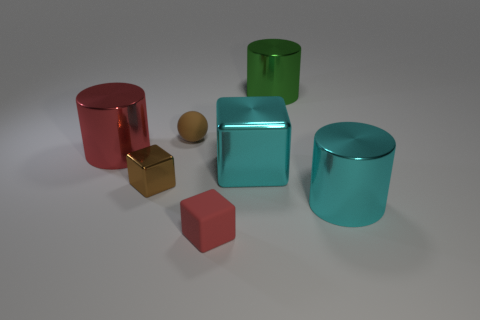How many objects are either objects in front of the big cyan metal cylinder or brown metallic things left of the big cyan cube?
Make the answer very short. 2. Is the number of red spheres less than the number of tiny spheres?
Give a very brief answer. Yes. Is the size of the brown matte thing the same as the cylinder that is to the left of the rubber cube?
Your answer should be compact. No. How many metallic things are either tiny red objects or cubes?
Your answer should be very brief. 2. Is the number of tiny red rubber things greater than the number of matte things?
Provide a short and direct response. No. There is a shiny object that is the same color as the big cube; what is its size?
Provide a succinct answer. Large. There is a small brown object that is in front of the tiny object behind the brown metallic object; what shape is it?
Give a very brief answer. Cube. There is a cyan object on the left side of the large thing that is in front of the big cube; are there any cyan blocks in front of it?
Your response must be concise. No. The matte thing that is the same size as the brown matte ball is what color?
Provide a short and direct response. Red. What shape is the large thing that is in front of the red shiny cylinder and behind the brown shiny cube?
Provide a short and direct response. Cube. 